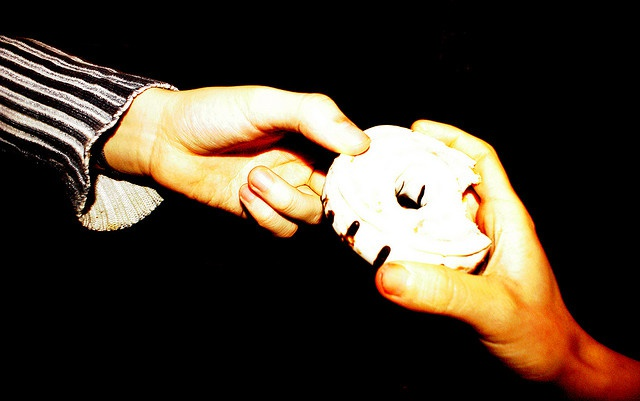Describe the objects in this image and their specific colors. I can see people in black, ivory, and khaki tones, people in black, lightyellow, gold, red, and brown tones, and donut in black, white, and khaki tones in this image. 